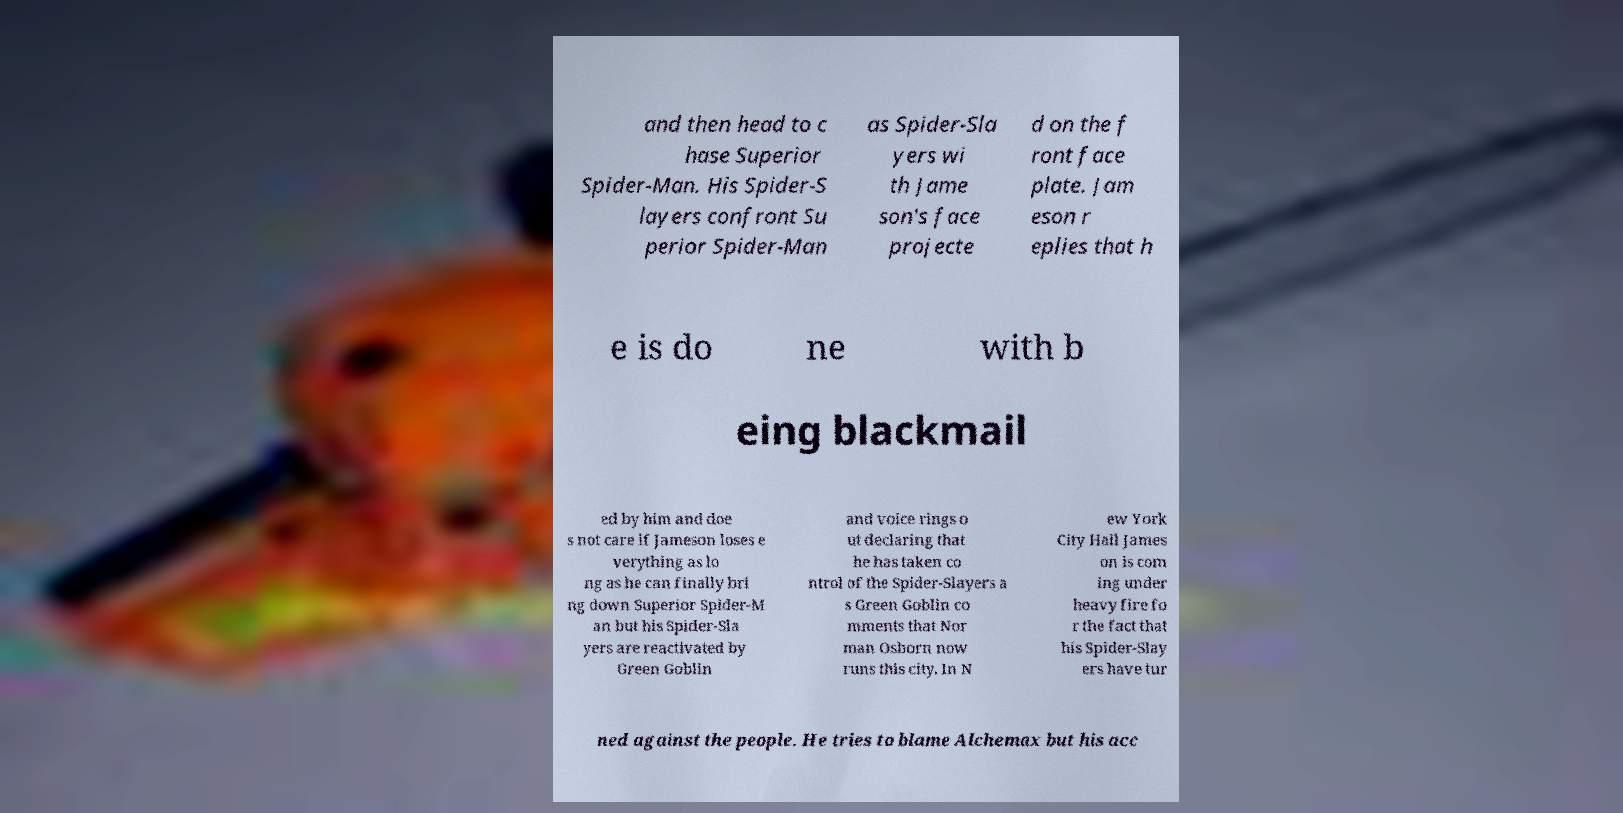For documentation purposes, I need the text within this image transcribed. Could you provide that? and then head to c hase Superior Spider-Man. His Spider-S layers confront Su perior Spider-Man as Spider-Sla yers wi th Jame son's face projecte d on the f ront face plate. Jam eson r eplies that h e is do ne with b eing blackmail ed by him and doe s not care if Jameson loses e verything as lo ng as he can finally bri ng down Superior Spider-M an but his Spider-Sla yers are reactivated by Green Goblin and voice rings o ut declaring that he has taken co ntrol of the Spider-Slayers a s Green Goblin co mments that Nor man Osborn now runs this city. In N ew York City Hall James on is com ing under heavy fire fo r the fact that his Spider-Slay ers have tur ned against the people. He tries to blame Alchemax but his acc 